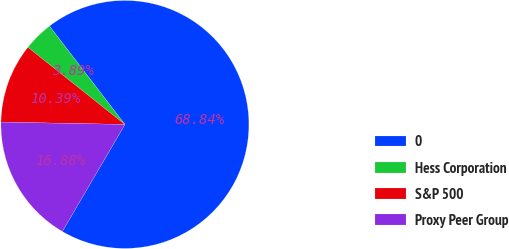Convert chart. <chart><loc_0><loc_0><loc_500><loc_500><pie_chart><fcel>0<fcel>Hess Corporation<fcel>S&P 500<fcel>Proxy Peer Group<nl><fcel>68.84%<fcel>3.89%<fcel>10.39%<fcel>16.88%<nl></chart> 